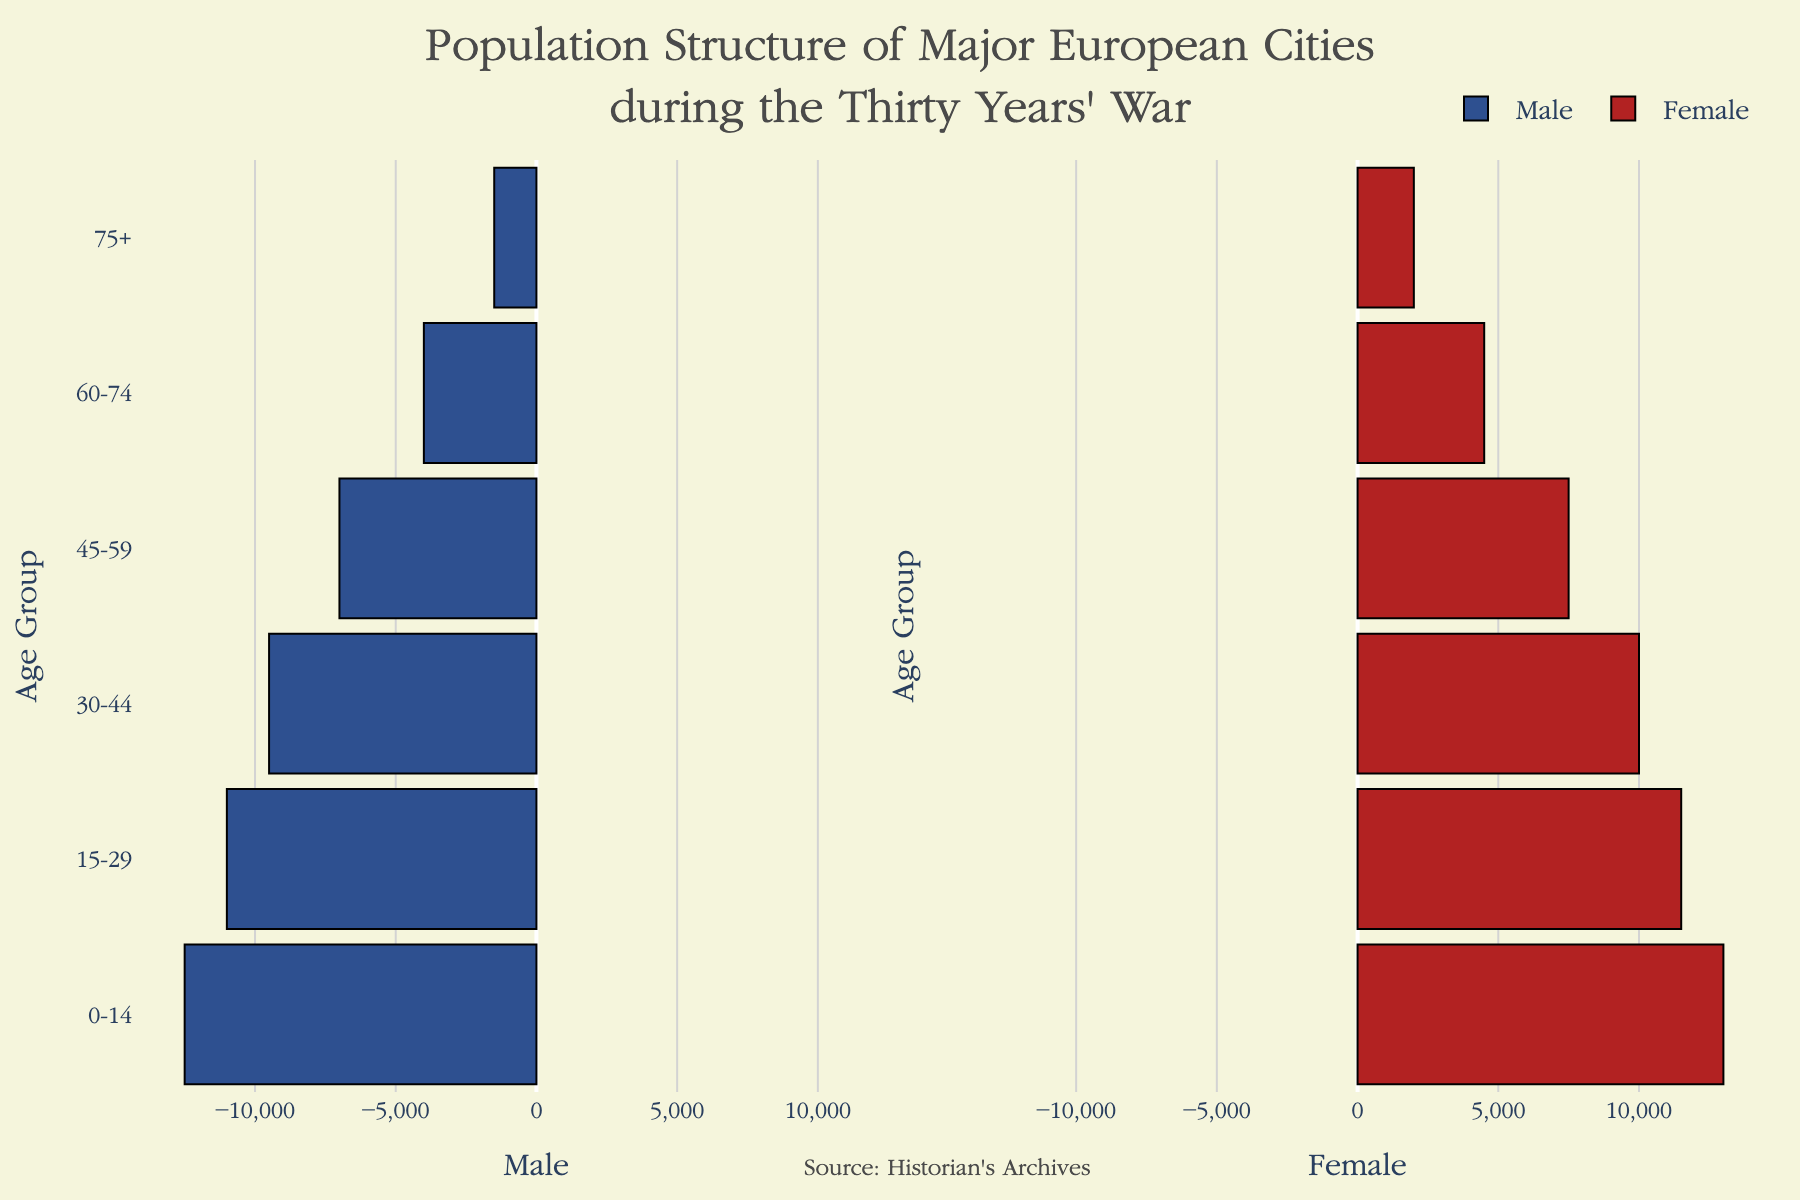What's the title of the figure? The title is prominently displayed at the top of the figure.
Answer: Population Structure of Major European Cities during the Thirty Years' War What colors represent males and females in the population pyramid? The color for males is a shade of blue, and the color for females is a shade of red. This is visible from the two bars on either side of the population pyramid.
Answer: Blue for males and red for females Which age group has the highest population for both males and females? Refer to the horizontal bars for each age group on the X-axis. The 0-14 age group has the longest bars for both males and females.
Answer: 0-14 What is the male-to-female ratio in the 30-44 age group? The population for males is 9500, and for females, it is 10000. The ratio is calculated as 9500 divided by 10000.
Answer: 0.95 Which age group has the smallest difference in population between males and females? Calculate the difference for each age group: 0-14: 500, 15-29: 500, 30-44: 500, 45-59: 500, 60-74: 500, 75+: 500. Each has an equal difference of 500.
Answer: All groups have a difference of 500 How does the population of males aged 60-74 compare to that of females aged 45-59? Males aged 60-74 have a population of 4000, whereas females aged 45-59 have 7500. Compare the numerical values.
Answer: Females aged 45-59 have a higher population Which age group shows a notable gender imbalance? The 75+ age group shows a higher imbalance, with females outnumbering males by 500.
Answer: 75+ What is the total population of females? Sum up the female populations for all age groups: 13000 + 11500 + 10000 + 7500 + 4500 + 2000 = 48500.
Answer: 48500 What is the average population per age group for males? The sum of the male populations is 12500 + 11000 + 9500 + 7000 + 4000 + 1500 = 45500. Divide this sum by the number of age groups (6).
Answer: 7583.33 Among the given age groups, where do the differences between male and female populations tend to be the smallest? All age groups show a 500 population difference. Each difference is identical.
Answer: All groups have the same difference 